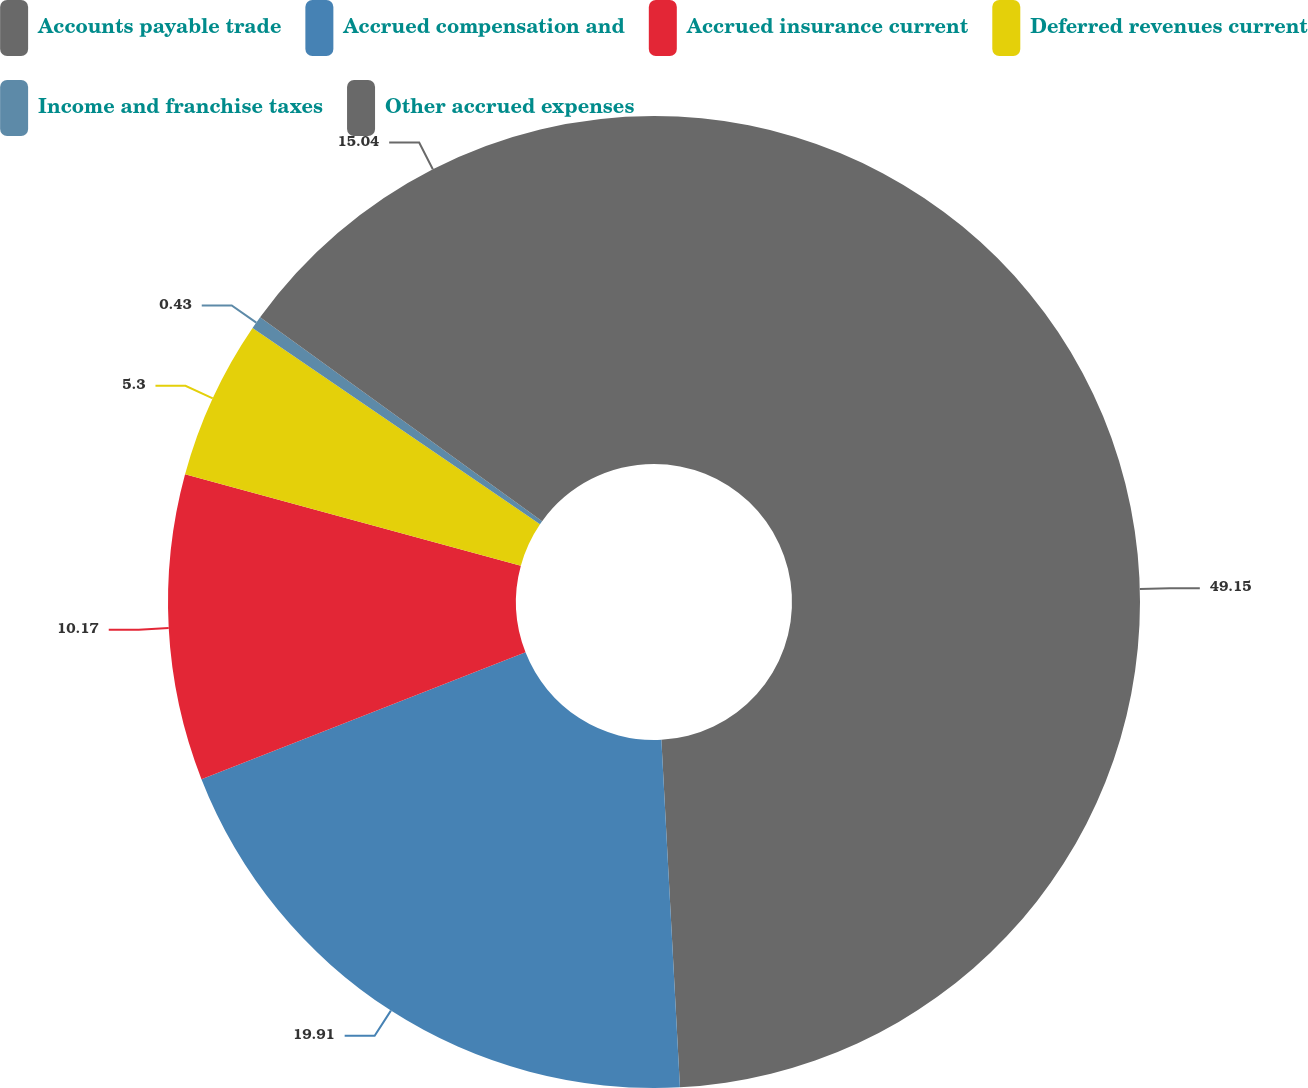Convert chart to OTSL. <chart><loc_0><loc_0><loc_500><loc_500><pie_chart><fcel>Accounts payable trade<fcel>Accrued compensation and<fcel>Accrued insurance current<fcel>Deferred revenues current<fcel>Income and franchise taxes<fcel>Other accrued expenses<nl><fcel>49.15%<fcel>19.91%<fcel>10.17%<fcel>5.3%<fcel>0.43%<fcel>15.04%<nl></chart> 